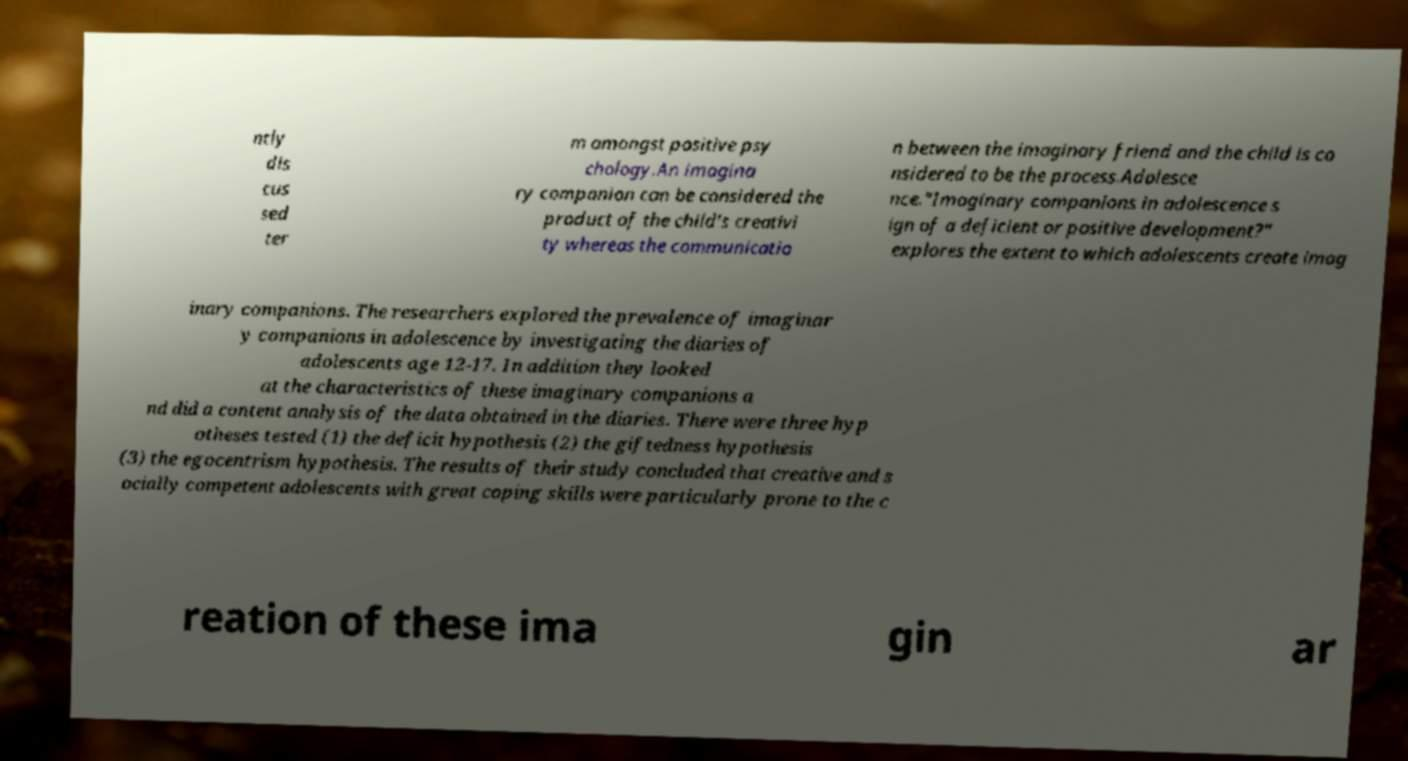What messages or text are displayed in this image? I need them in a readable, typed format. ntly dis cus sed ter m amongst positive psy chology.An imagina ry companion can be considered the product of the child's creativi ty whereas the communicatio n between the imaginary friend and the child is co nsidered to be the process.Adolesce nce."Imaginary companions in adolescence s ign of a deficient or positive development?" explores the extent to which adolescents create imag inary companions. The researchers explored the prevalence of imaginar y companions in adolescence by investigating the diaries of adolescents age 12-17. In addition they looked at the characteristics of these imaginary companions a nd did a content analysis of the data obtained in the diaries. There were three hyp otheses tested (1) the deficit hypothesis (2) the giftedness hypothesis (3) the egocentrism hypothesis. The results of their study concluded that creative and s ocially competent adolescents with great coping skills were particularly prone to the c reation of these ima gin ar 